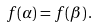Convert formula to latex. <formula><loc_0><loc_0><loc_500><loc_500>f ( \alpha ) = f ( \beta ) \, .</formula> 